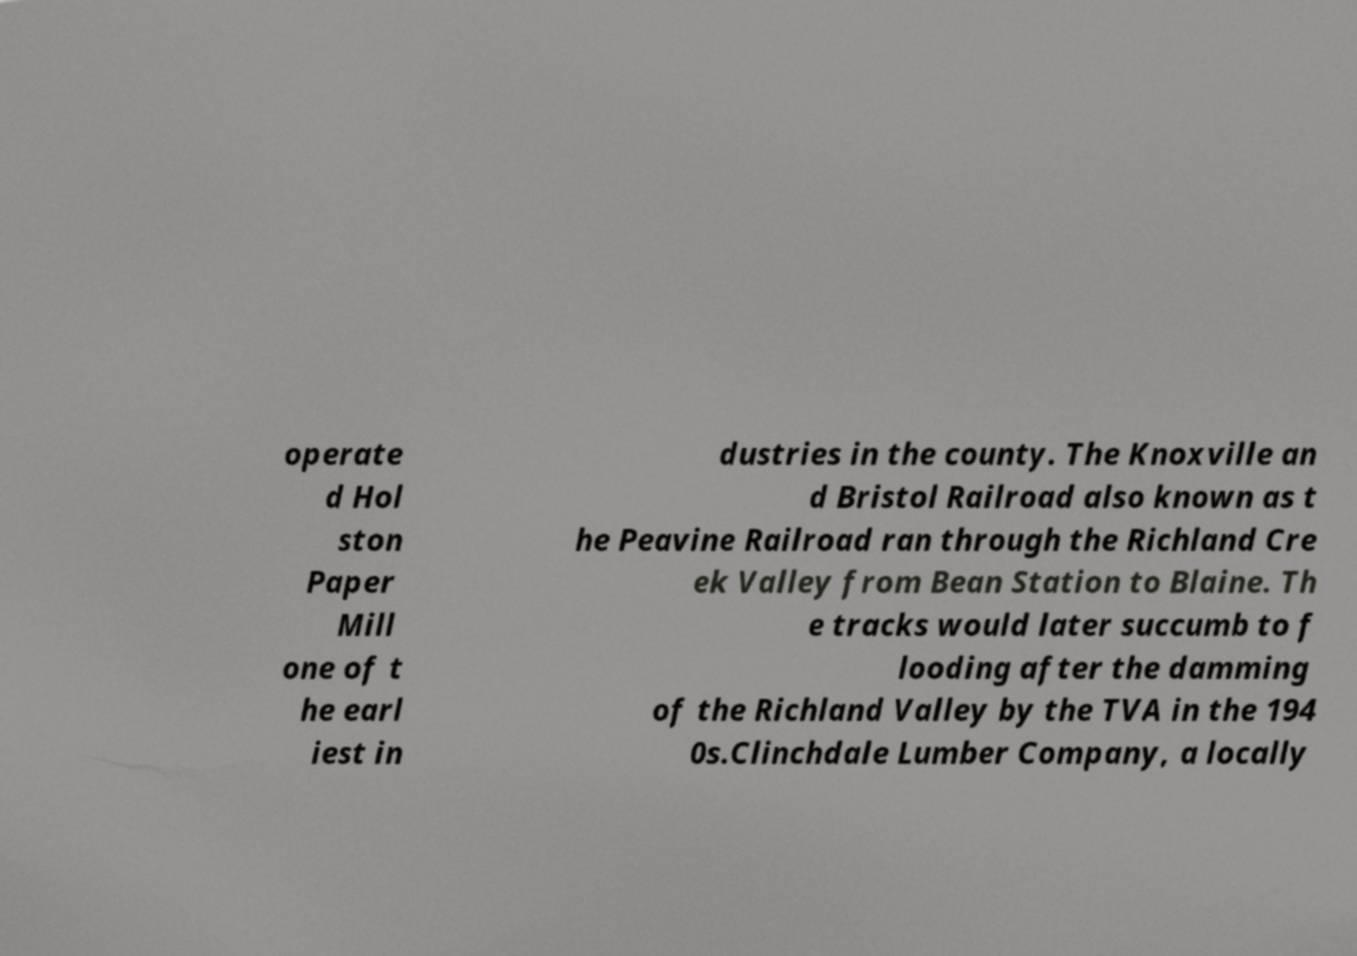Please read and relay the text visible in this image. What does it say? operate d Hol ston Paper Mill one of t he earl iest in dustries in the county. The Knoxville an d Bristol Railroad also known as t he Peavine Railroad ran through the Richland Cre ek Valley from Bean Station to Blaine. Th e tracks would later succumb to f looding after the damming of the Richland Valley by the TVA in the 194 0s.Clinchdale Lumber Company, a locally 